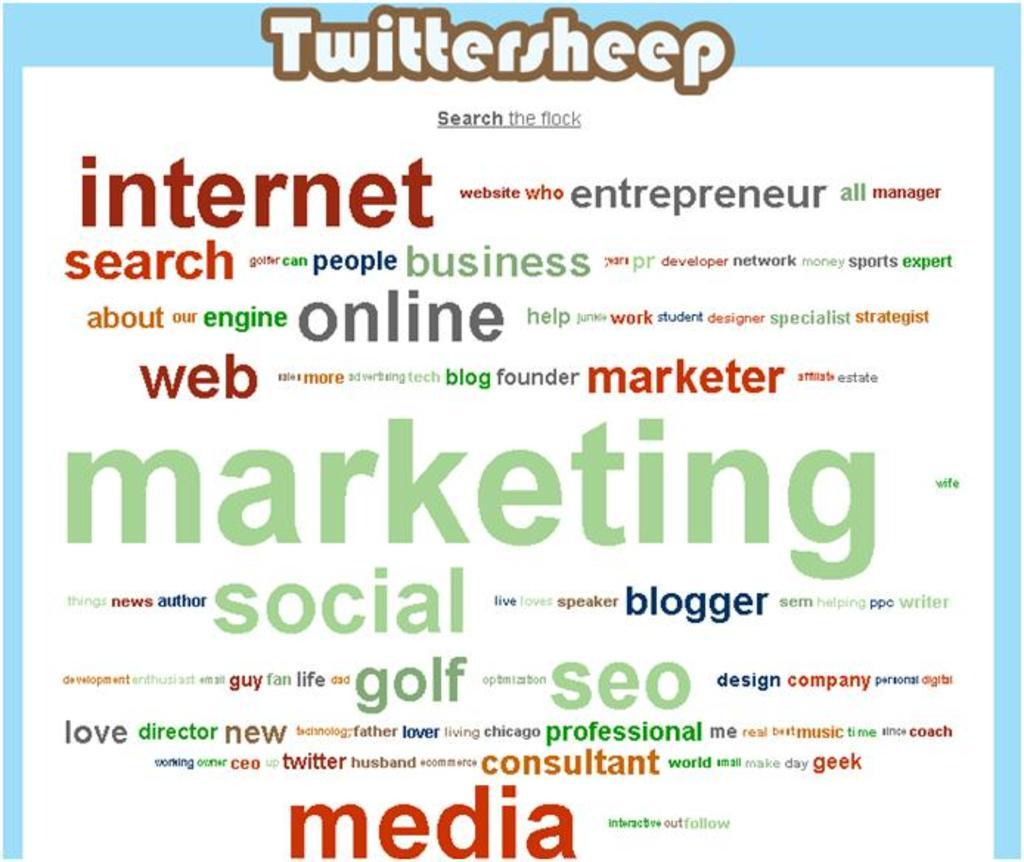What type of image is being described? The image is a web page. What can be found on the web page? There are words on the web page. What type of music is playing in the background of the web page? There is no music playing in the background of the web page, as the facts provided do not mention any audio elements. 